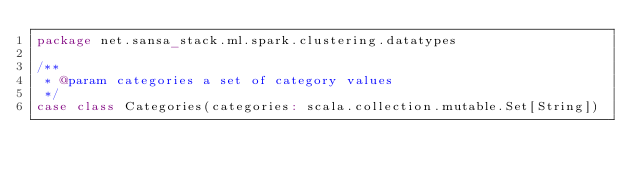Convert code to text. <code><loc_0><loc_0><loc_500><loc_500><_Scala_>package net.sansa_stack.ml.spark.clustering.datatypes

/**
 * @param categories a set of category values
 */
case class Categories(categories: scala.collection.mutable.Set[String])

</code> 